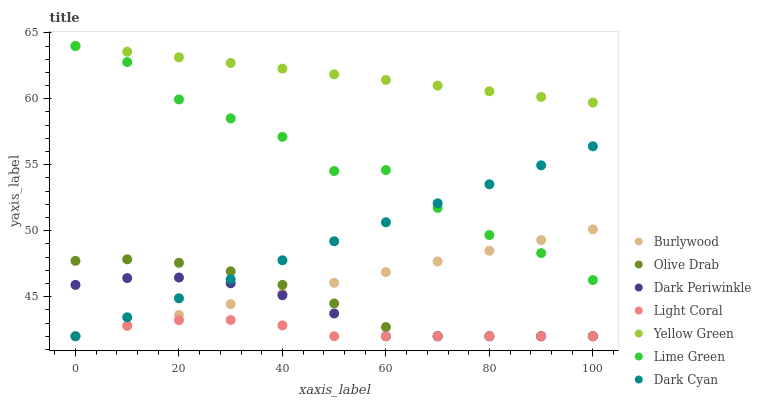Does Light Coral have the minimum area under the curve?
Answer yes or no. Yes. Does Yellow Green have the maximum area under the curve?
Answer yes or no. Yes. Does Burlywood have the minimum area under the curve?
Answer yes or no. No. Does Burlywood have the maximum area under the curve?
Answer yes or no. No. Is Yellow Green the smoothest?
Answer yes or no. Yes. Is Lime Green the roughest?
Answer yes or no. Yes. Is Burlywood the smoothest?
Answer yes or no. No. Is Burlywood the roughest?
Answer yes or no. No. Does Burlywood have the lowest value?
Answer yes or no. Yes. Does Lime Green have the lowest value?
Answer yes or no. No. Does Lime Green have the highest value?
Answer yes or no. Yes. Does Burlywood have the highest value?
Answer yes or no. No. Is Dark Periwinkle less than Yellow Green?
Answer yes or no. Yes. Is Lime Green greater than Olive Drab?
Answer yes or no. Yes. Does Dark Cyan intersect Light Coral?
Answer yes or no. Yes. Is Dark Cyan less than Light Coral?
Answer yes or no. No. Is Dark Cyan greater than Light Coral?
Answer yes or no. No. Does Dark Periwinkle intersect Yellow Green?
Answer yes or no. No. 